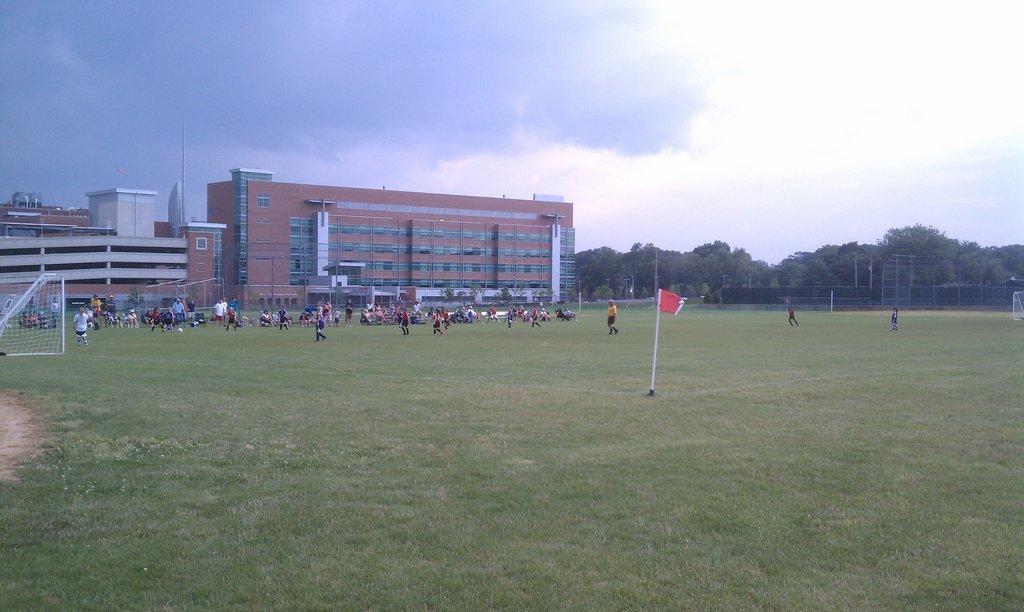Can you describe this image briefly? In this image we can see one big football playground, one flag, some people are playing football, one big building, some trees, two nets, some grass on the ground, some objects are on the surface, one ball on the ground, some poles and at the top there is the sky. Some people are sitting and some people are standing on the ground. 